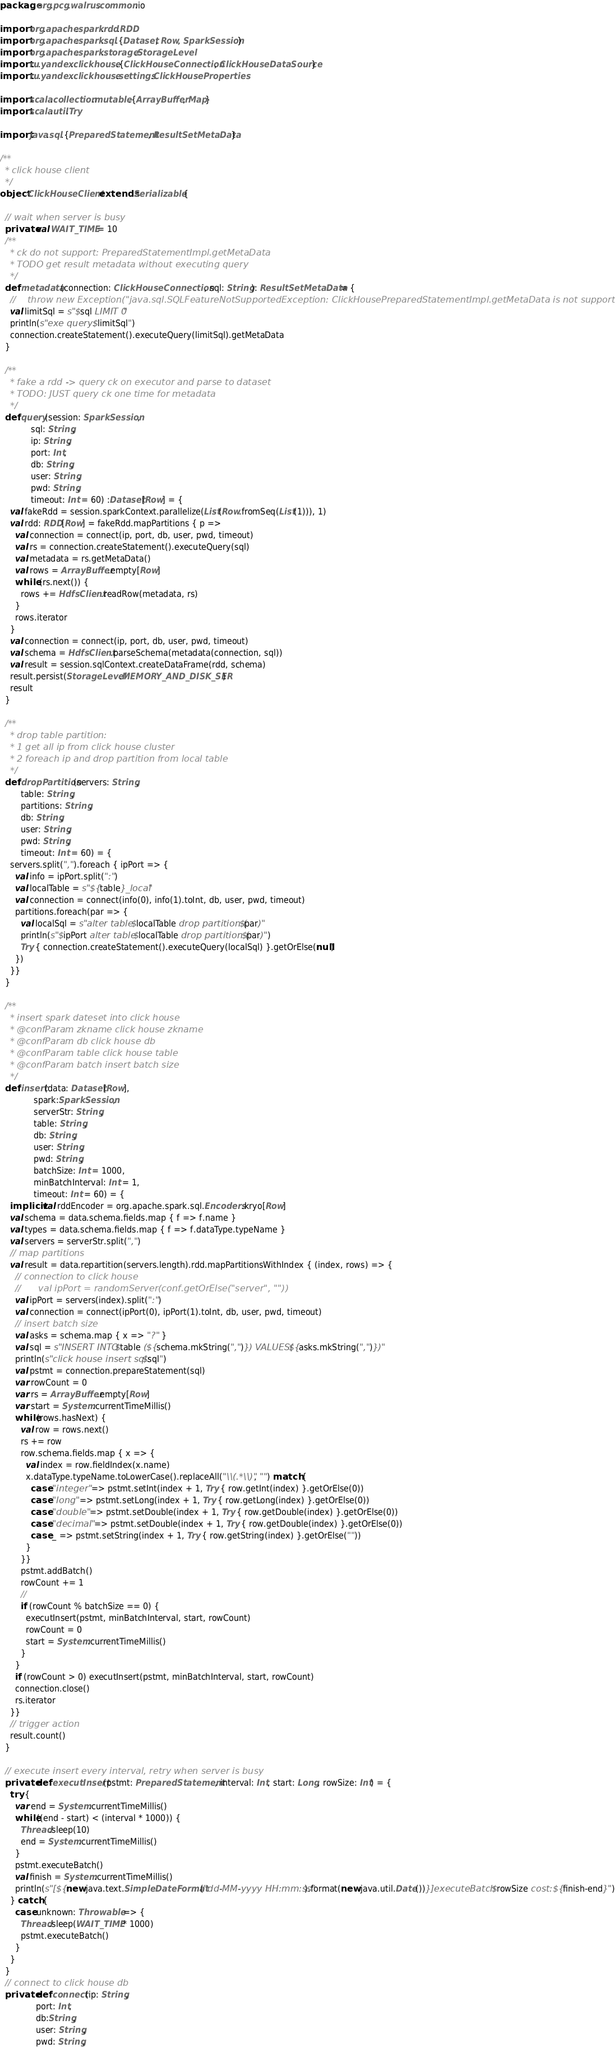<code> <loc_0><loc_0><loc_500><loc_500><_Scala_>package org.pcg.walrus.common.io

import org.apache.spark.rdd.RDD
import org.apache.spark.sql.{Dataset, Row, SparkSession}
import org.apache.spark.storage.StorageLevel
import ru.yandex.clickhouse.{ClickHouseConnection, ClickHouseDataSource}
import ru.yandex.clickhouse.settings.ClickHouseProperties

import scala.collection.mutable.{ArrayBuffer, Map}
import scala.util.Try

import java.sql.{PreparedStatement, ResultSetMetaData}

/**
  * click house client
  */
object ClickHouseClient extends Serializable {

  // wait when server is busy
  private val WAIT_TIME = 10
  /**
    * ck do not support: PreparedStatementImpl.getMetaData
    * TODO get result metadata without executing query
    */
  def metadata(connection: ClickHouseConnection, sql: String): ResultSetMetaData = {
    //    throw new Exception("java.sql.SQLFeatureNotSupportedException: ClickHousePreparedStatementImpl.getMetaData is not supported!")
    val limitSql = s"$sql LIMIT 0"
    println(s"exe query: $limitSql")
    connection.createStatement().executeQuery(limitSql).getMetaData
  }

  /**
    * fake a rdd -> query ck on executor and parse to dataset
    * TODO: JUST query ck one time for metadata
    */
  def query(session: SparkSession,
            sql: String,
            ip: String,
            port: Int,
            db: String,
            user: String,
            pwd: String,
            timeout: Int = 60) :Dataset[Row] = {
    val fakeRdd = session.sparkContext.parallelize(List(Row.fromSeq(List(1))), 1)
    val rdd: RDD[Row] = fakeRdd.mapPartitions { p =>
      val connection = connect(ip, port, db, user, pwd, timeout)
      val rs = connection.createStatement().executeQuery(sql)
      val metadata = rs.getMetaData()
      val rows = ArrayBuffer.empty[Row]
      while (rs.next()) {
        rows += HdfsClient.readRow(metadata, rs)
      }
      rows.iterator
    }
    val connection = connect(ip, port, db, user, pwd, timeout)
    val schema = HdfsClient.parseSchema(metadata(connection, sql))
    val result = session.sqlContext.createDataFrame(rdd, schema)
    result.persist(StorageLevel.MEMORY_AND_DISK_SER)
    result
  }

  /**
    * drop table partition:
    * 1 get all ip from click house cluster
    * 2 foreach ip and drop partition from local table
    */
  def dropPartition(servers: String,
        table: String,
        partitions: String,
        db: String,
        user: String,
        pwd: String,
        timeout: Int = 60) = {
    servers.split(",").foreach { ipPort => {
      val info = ipPort.split(":")
      val localTable = s"${table}_local"
      val connection = connect(info(0), info(1).toInt, db, user, pwd, timeout)
      partitions.foreach(par => {
        val localSql = s"alter table $localTable drop partition ($par)"
        println(s"$ipPort alter table $localTable drop partition ($par)")
        Try { connection.createStatement().executeQuery(localSql) }.getOrElse(null)
      })
    }}
  }

  /**
    * insert spark dateset into click house
    * @confParam zkname click house zkname
    * @confParam db click house db
    * @confParam table click house table
    * @confParam batch insert batch size
    */
  def insert(data: Dataset[Row],
             spark:SparkSession,
             serverStr: String,
             table: String,
             db: String,
             user: String,
             pwd: String,
             batchSize: Int = 1000,
             minBatchInterval: Int = 1,
             timeout: Int = 60) = {
    implicit val rddEncoder = org.apache.spark.sql.Encoders.kryo[Row]
    val schema = data.schema.fields.map { f => f.name }
    val types = data.schema.fields.map { f => f.dataType.typeName }
    val servers = serverStr.split(",")
    // map partitions
    val result = data.repartition(servers.length).rdd.mapPartitionsWithIndex { (index, rows) => {
      // connection to click house
      //      val ipPort = randomServer(conf.getOrElse("server", ""))
      val ipPort = servers(index).split(":")
      val connection = connect(ipPort(0), ipPort(1).toInt, db, user, pwd, timeout)
      // insert batch size
      val asks = schema.map { x => "?" }
      val sql = s"INSERT INTO $table (${schema.mkString(",")}) VALUES(${asks.mkString(",")})"
      println(s"click house insert sql: $sql")
      val pstmt = connection.prepareStatement(sql)
      var rowCount = 0
      var rs = ArrayBuffer.empty[Row]
      var start = System.currentTimeMillis()
      while(rows.hasNext) {
        val row = rows.next()
        rs += row
        row.schema.fields.map { x => {
          val index = row.fieldIndex(x.name)
          x.dataType.typeName.toLowerCase().replaceAll("\\(.*\\)", "") match {
            case "integer" => pstmt.setInt(index + 1, Try { row.getInt(index) }.getOrElse(0))
            case "long" => pstmt.setLong(index + 1, Try { row.getLong(index) }.getOrElse(0))
            case "double" => pstmt.setDouble(index + 1, Try { row.getDouble(index) }.getOrElse(0))
            case "decimal" => pstmt.setDouble(index + 1, Try { row.getDouble(index) }.getOrElse(0))
            case _ => pstmt.setString(index + 1, Try { row.getString(index) }.getOrElse(""))
          }
        }}
        pstmt.addBatch()
        rowCount += 1
        //
        if (rowCount % batchSize == 0) {
          executInsert(pstmt, minBatchInterval, start, rowCount)
          rowCount = 0
          start = System.currentTimeMillis()
        }
      }
      if (rowCount > 0) executInsert(pstmt, minBatchInterval, start, rowCount)
      connection.close()
      rs.iterator
    }}
    // trigger action
    result.count()
  }

  // execute insert every interval, retry when server is busy
  private def executInsert(pstmt: PreparedStatement, interval: Int, start: Long, rowSize: Int) = {
    try {
      var end = System.currentTimeMillis()
      while((end - start) < (interval * 1000)) {
        Thread.sleep(10)
        end = System.currentTimeMillis()
      }
      pstmt.executeBatch()
      val finish = System.currentTimeMillis()
      println(s"[${new java.text.SimpleDateFormat("dd-MM-yyyy HH:mm:ss").format(new java.util.Date())}]executeBatch $rowSize cost: ${finish-end}")
    } catch {
      case unknown: Throwable => {
        Thread.sleep(WAIT_TIME * 1000)
        pstmt.executeBatch()
      }
    }
  }
  // connect to click house db
  private def connect(ip: String,
              port: Int,
              db:String,
              user: String,
              pwd: String,</code> 